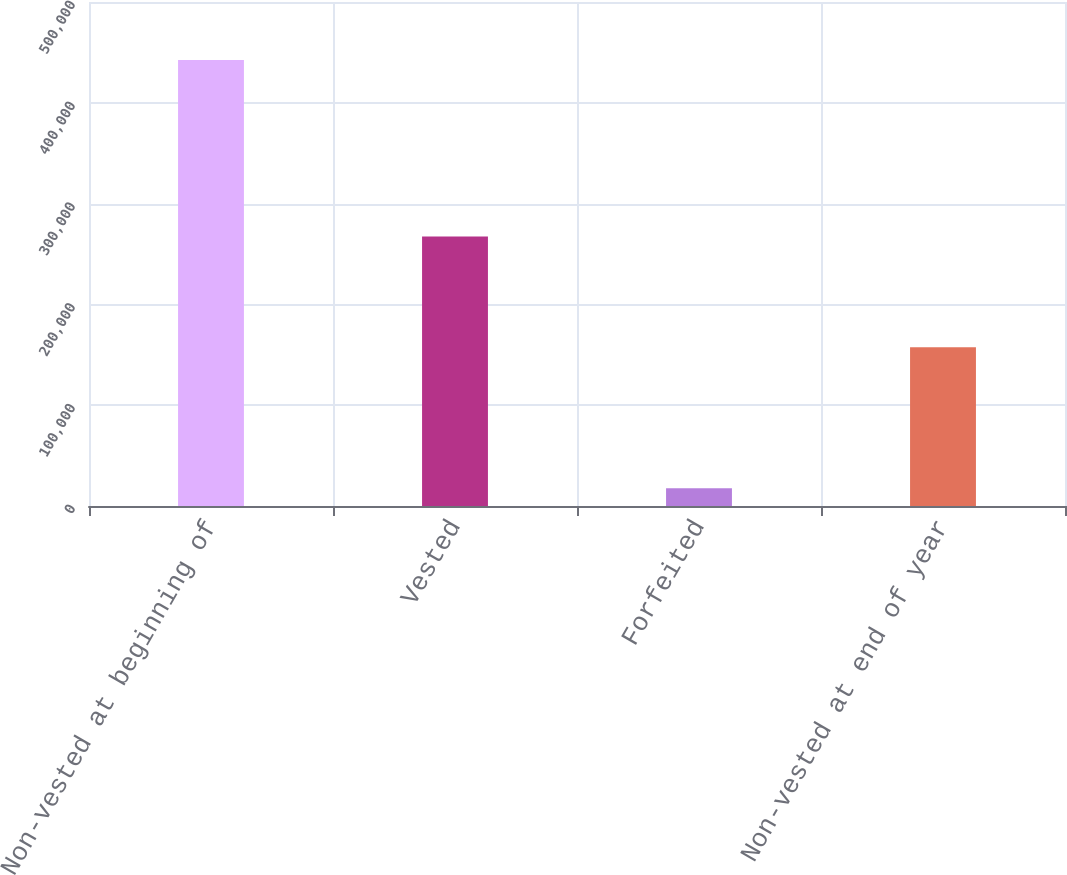<chart> <loc_0><loc_0><loc_500><loc_500><bar_chart><fcel>Non-vested at beginning of<fcel>Vested<fcel>Forfeited<fcel>Non-vested at end of year<nl><fcel>442435<fcel>267400<fcel>17559<fcel>157476<nl></chart> 